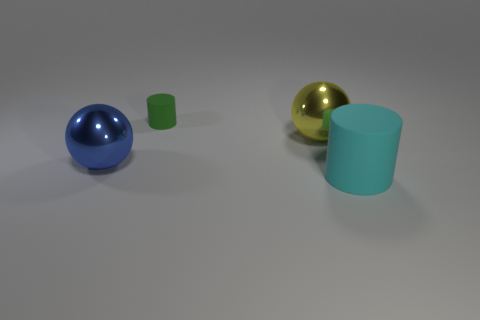Is there any other thing that has the same material as the cyan thing?
Your answer should be very brief. Yes. Are there any yellow balls on the right side of the cyan cylinder?
Offer a terse response. No. How many large brown metallic objects are there?
Keep it short and to the point. 0. How many big cyan objects are behind the matte cylinder in front of the large blue object?
Provide a short and direct response. 0. There is a tiny matte object; is its color the same as the big thing that is to the left of the small cylinder?
Give a very brief answer. No. How many big metallic things have the same shape as the tiny green object?
Your answer should be very brief. 0. There is a cylinder that is in front of the yellow metallic thing; what is it made of?
Ensure brevity in your answer.  Rubber. There is a big shiny thing on the left side of the yellow object; is its shape the same as the green rubber object?
Offer a terse response. No. Is there a yellow metallic object of the same size as the green rubber cylinder?
Offer a very short reply. No. There is a big matte object; does it have the same shape as the yellow object on the right side of the tiny cylinder?
Make the answer very short. No. 